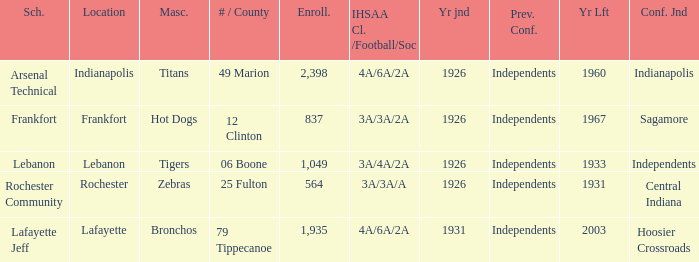What is the lowest enrollment that has Lafayette as the location? 1935.0. 